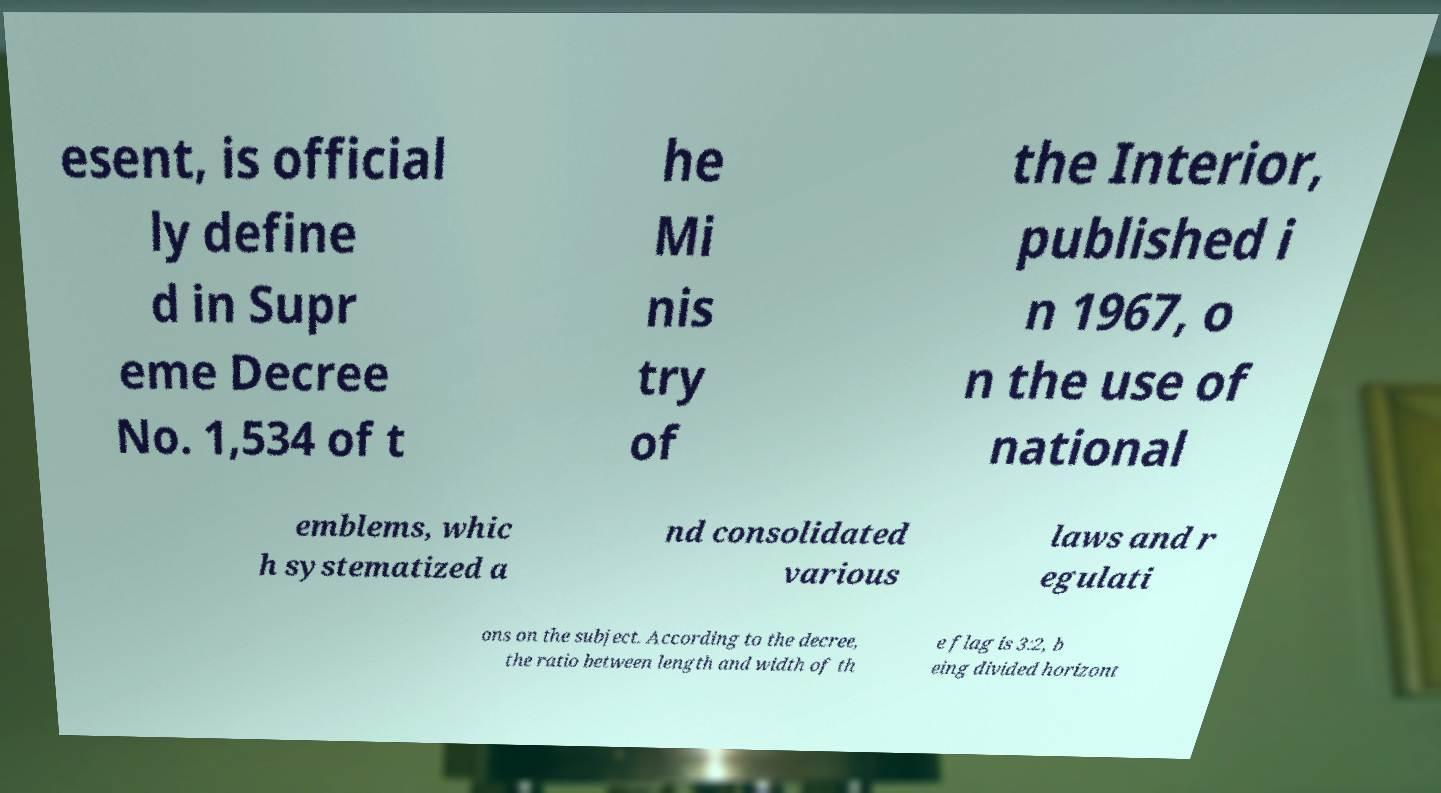What messages or text are displayed in this image? I need them in a readable, typed format. esent, is official ly define d in Supr eme Decree No. 1,534 of t he Mi nis try of the Interior, published i n 1967, o n the use of national emblems, whic h systematized a nd consolidated various laws and r egulati ons on the subject. According to the decree, the ratio between length and width of th e flag is 3:2, b eing divided horizont 